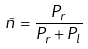<formula> <loc_0><loc_0><loc_500><loc_500>\tilde { n } = \frac { P _ { r } } { P _ { r } + P _ { l } }</formula> 